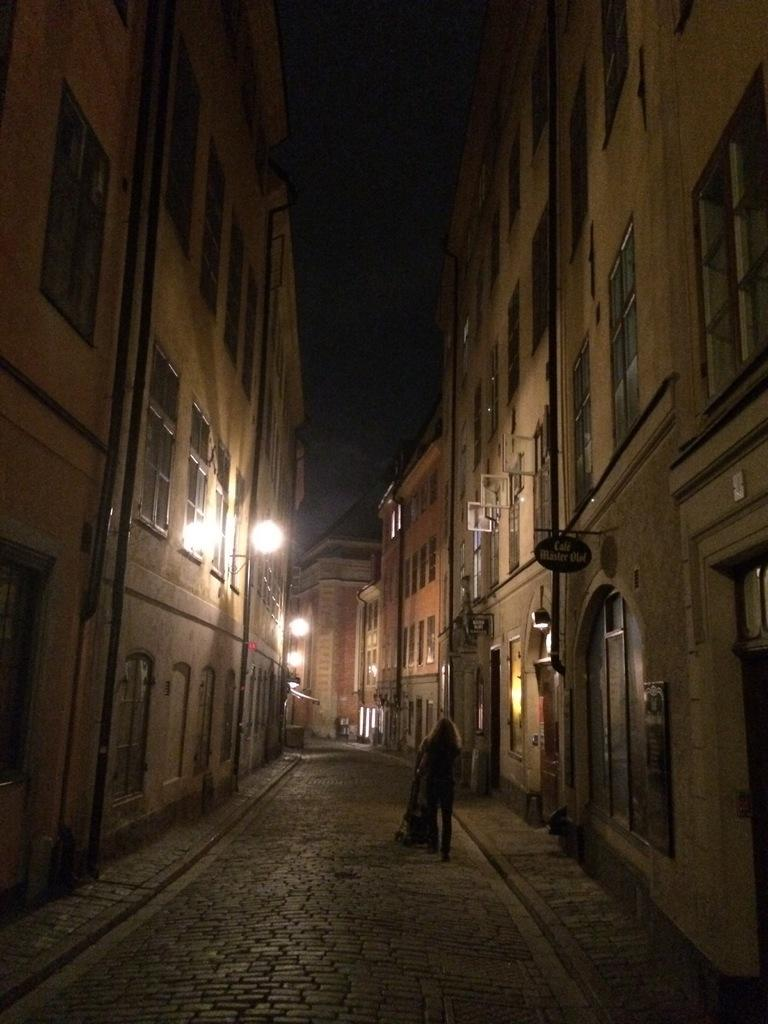What is the main subject in the center of the image? There is a person in the center of the image. What can be seen on the right side of the image? There are buildings on the right side of the image. What can be seen on the left side of the image? There are buildings on the left side of the image. What is illuminating the scene in the image? There are lights visible in the image. What is visible in the background of the image? The sky is visible in the background of the image. What type of animal is the person reading to in the image? There is no animal present in the image, nor is there any indication that the person is reading to anyone or anything. 